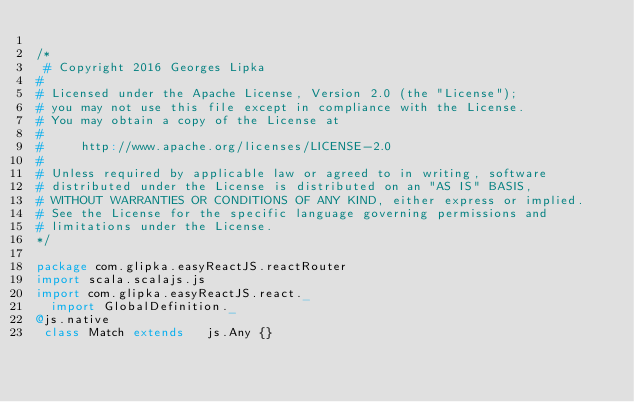Convert code to text. <code><loc_0><loc_0><loc_500><loc_500><_Scala_> 
/*
 # Copyright 2016 Georges Lipka
#
# Licensed under the Apache License, Version 2.0 (the "License");
# you may not use this file except in compliance with the License.
# You may obtain a copy of the License at
#
#     http://www.apache.org/licenses/LICENSE-2.0
#
# Unless required by applicable law or agreed to in writing, software
# distributed under the License is distributed on an "AS IS" BASIS,
# WITHOUT WARRANTIES OR CONDITIONS OF ANY KIND, either express or implied.
# See the License for the specific language governing permissions and
# limitations under the License.
*/
 
package com.glipka.easyReactJS.reactRouter
import scala.scalajs.js 
import com.glipka.easyReactJS.react._
  import GlobalDefinition._
@js.native
 class Match extends   js.Any {}</code> 